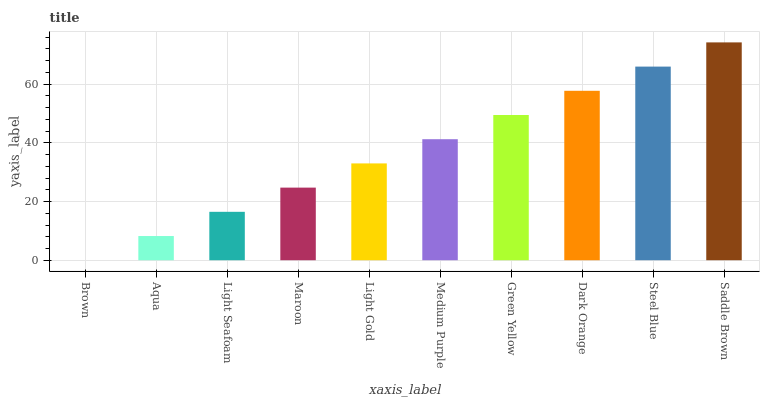Is Brown the minimum?
Answer yes or no. Yes. Is Saddle Brown the maximum?
Answer yes or no. Yes. Is Aqua the minimum?
Answer yes or no. No. Is Aqua the maximum?
Answer yes or no. No. Is Aqua greater than Brown?
Answer yes or no. Yes. Is Brown less than Aqua?
Answer yes or no. Yes. Is Brown greater than Aqua?
Answer yes or no. No. Is Aqua less than Brown?
Answer yes or no. No. Is Medium Purple the high median?
Answer yes or no. Yes. Is Light Gold the low median?
Answer yes or no. Yes. Is Maroon the high median?
Answer yes or no. No. Is Aqua the low median?
Answer yes or no. No. 